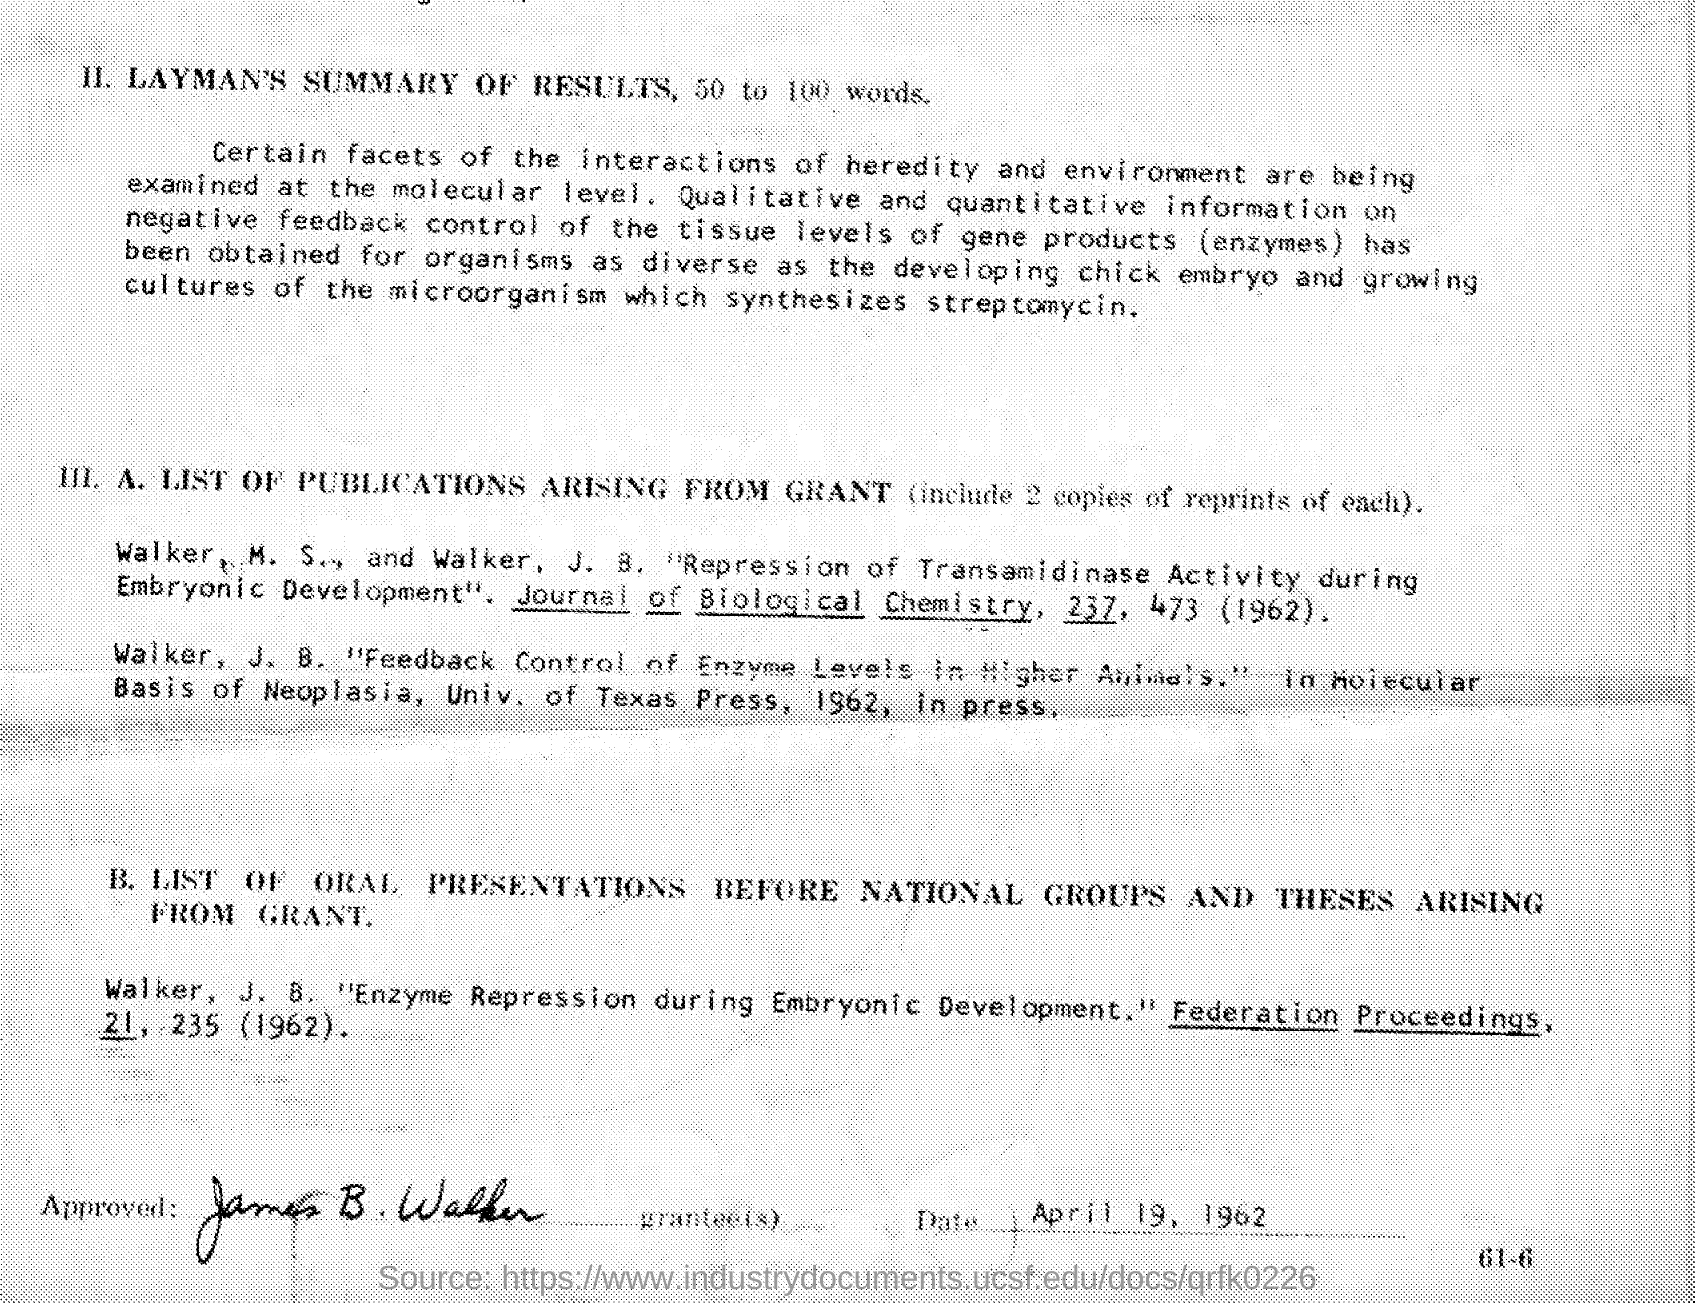What is the date at the bottom of the document?
Provide a short and direct response. April 19, 1962. Who approved the document?
Give a very brief answer. James B. Walker. 